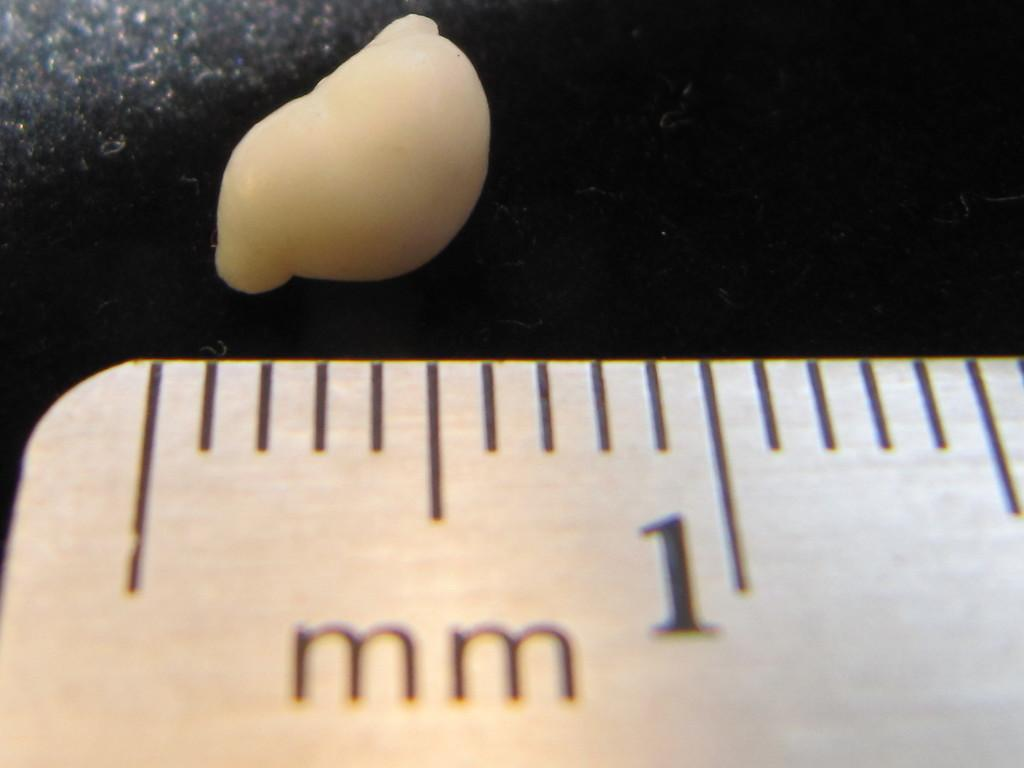<image>
Write a terse but informative summary of the picture. A ruler showing the first mm and measuring a peanut. 